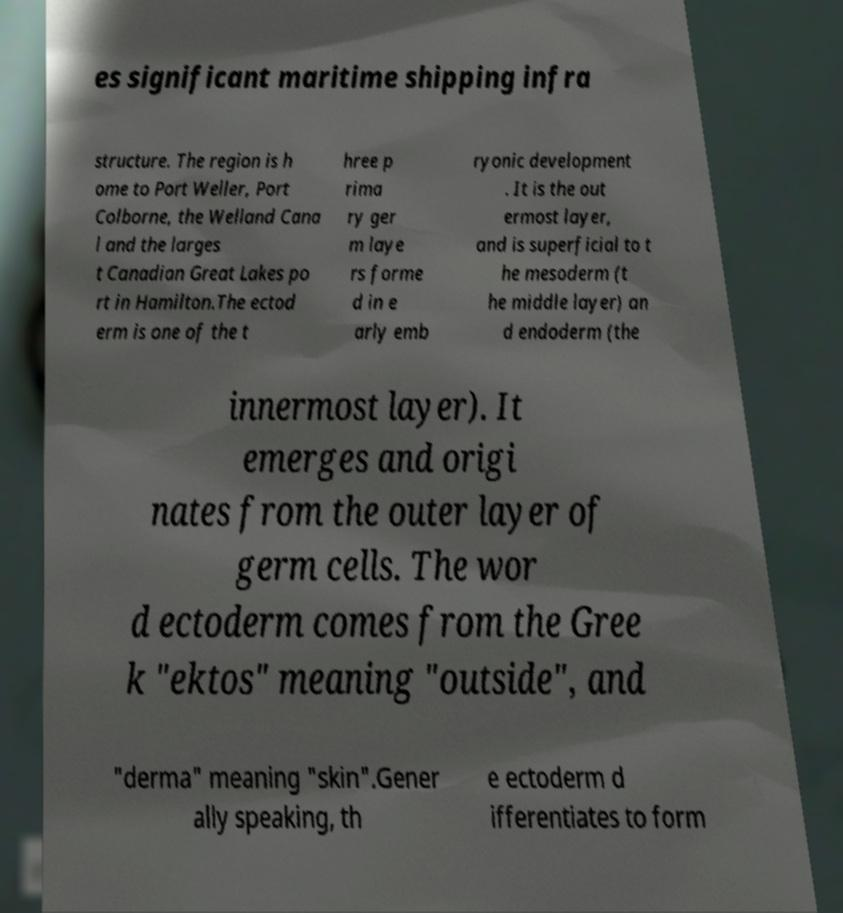What messages or text are displayed in this image? I need them in a readable, typed format. es significant maritime shipping infra structure. The region is h ome to Port Weller, Port Colborne, the Welland Cana l and the larges t Canadian Great Lakes po rt in Hamilton.The ectod erm is one of the t hree p rima ry ger m laye rs forme d in e arly emb ryonic development . It is the out ermost layer, and is superficial to t he mesoderm (t he middle layer) an d endoderm (the innermost layer). It emerges and origi nates from the outer layer of germ cells. The wor d ectoderm comes from the Gree k "ektos" meaning "outside", and "derma" meaning "skin".Gener ally speaking, th e ectoderm d ifferentiates to form 